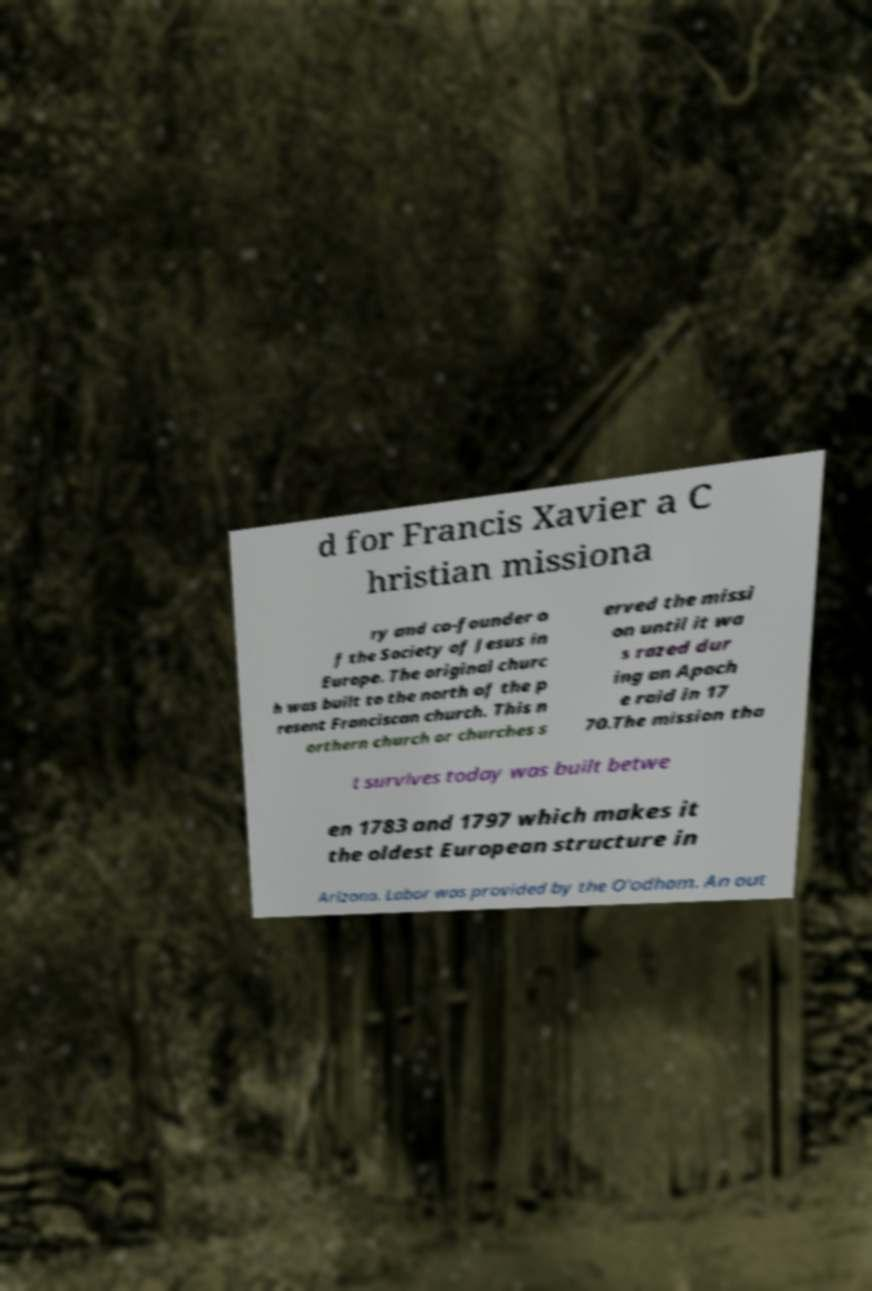Please read and relay the text visible in this image. What does it say? d for Francis Xavier a C hristian missiona ry and co-founder o f the Society of Jesus in Europe. The original churc h was built to the north of the p resent Franciscan church. This n orthern church or churches s erved the missi on until it wa s razed dur ing an Apach e raid in 17 70.The mission tha t survives today was built betwe en 1783 and 1797 which makes it the oldest European structure in Arizona. Labor was provided by the O'odham. An out 